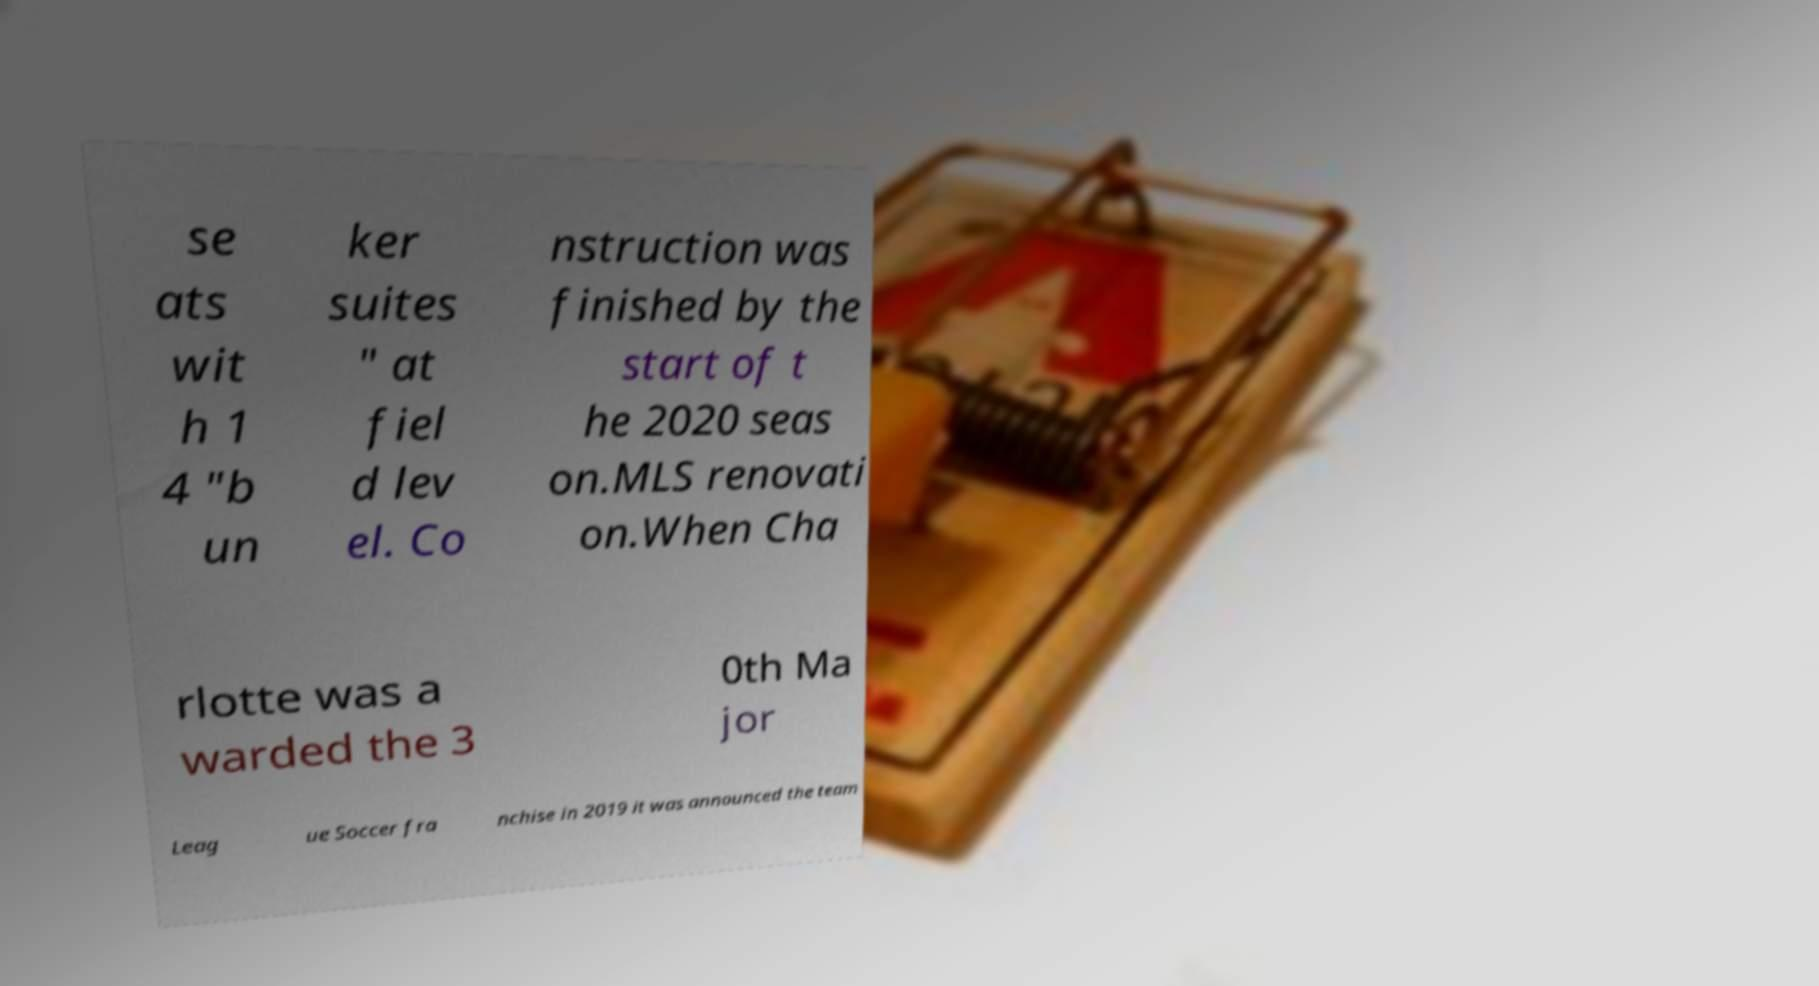Please identify and transcribe the text found in this image. se ats wit h 1 4 "b un ker suites " at fiel d lev el. Co nstruction was finished by the start of t he 2020 seas on.MLS renovati on.When Cha rlotte was a warded the 3 0th Ma jor Leag ue Soccer fra nchise in 2019 it was announced the team 